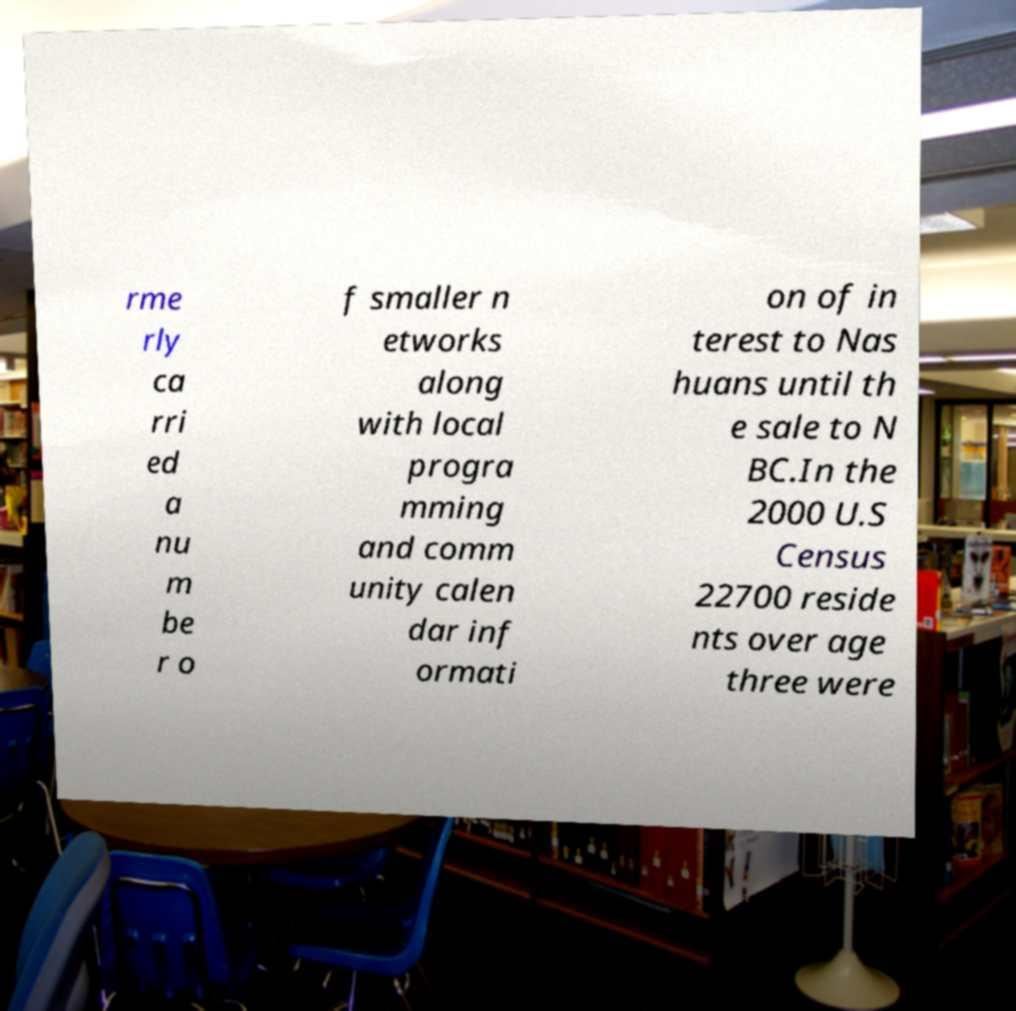Can you accurately transcribe the text from the provided image for me? rme rly ca rri ed a nu m be r o f smaller n etworks along with local progra mming and comm unity calen dar inf ormati on of in terest to Nas huans until th e sale to N BC.In the 2000 U.S Census 22700 reside nts over age three were 